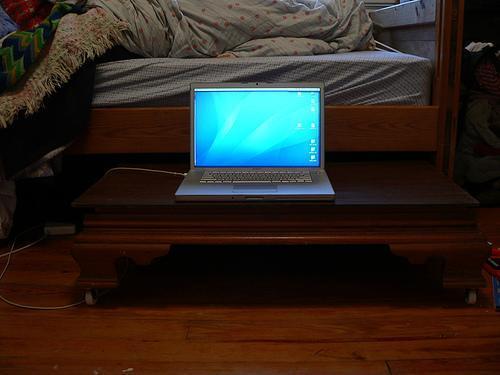How many mirrors are there?
Give a very brief answer. 0. 